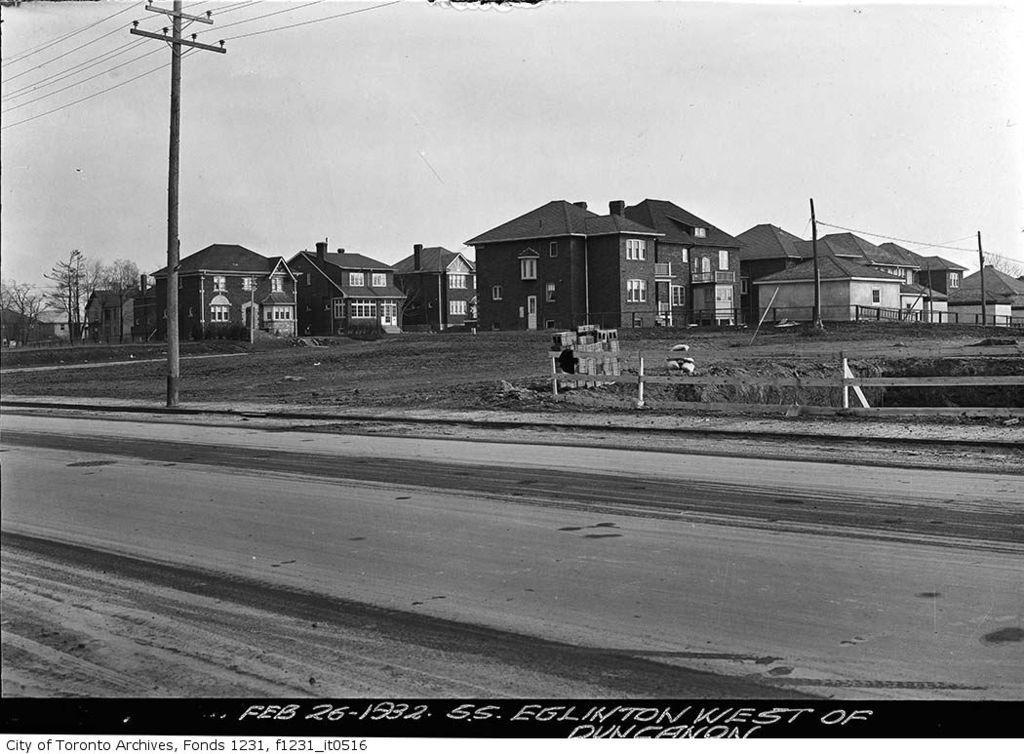Can you describe this image briefly? This image is a black and white image. This image is taken outdoors. At the top of the image there is the sky. At the bottom of the image there is a text on this image and there is a road. In the middle of the image there are many houses. There are a few trees. There are a few poles with street lights and wires. There is a fence. There are a few objects on the ground. 